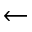<formula> <loc_0><loc_0><loc_500><loc_500>\leftarrow</formula> 